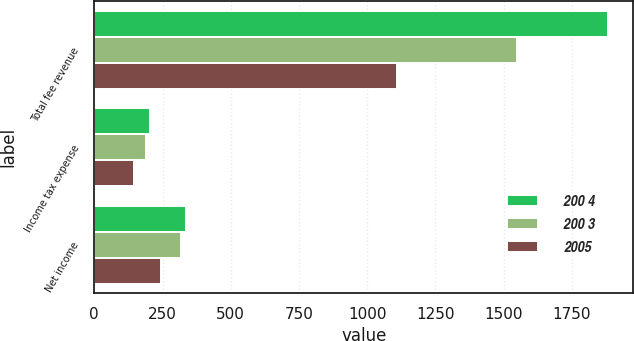Convert chart to OTSL. <chart><loc_0><loc_0><loc_500><loc_500><stacked_bar_chart><ecel><fcel>Total fee revenue<fcel>Income tax expense<fcel>Net income<nl><fcel>200 4<fcel>1881<fcel>205<fcel>336<nl><fcel>200 3<fcel>1549<fcel>191<fcel>316<nl><fcel>2005<fcel>1111<fcel>146<fcel>244<nl></chart> 